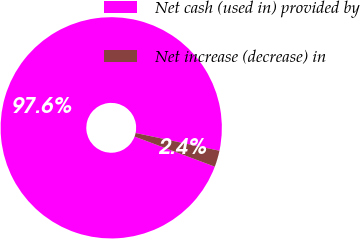<chart> <loc_0><loc_0><loc_500><loc_500><pie_chart><fcel>Net cash (used in) provided by<fcel>Net increase (decrease) in<nl><fcel>97.61%<fcel>2.39%<nl></chart> 